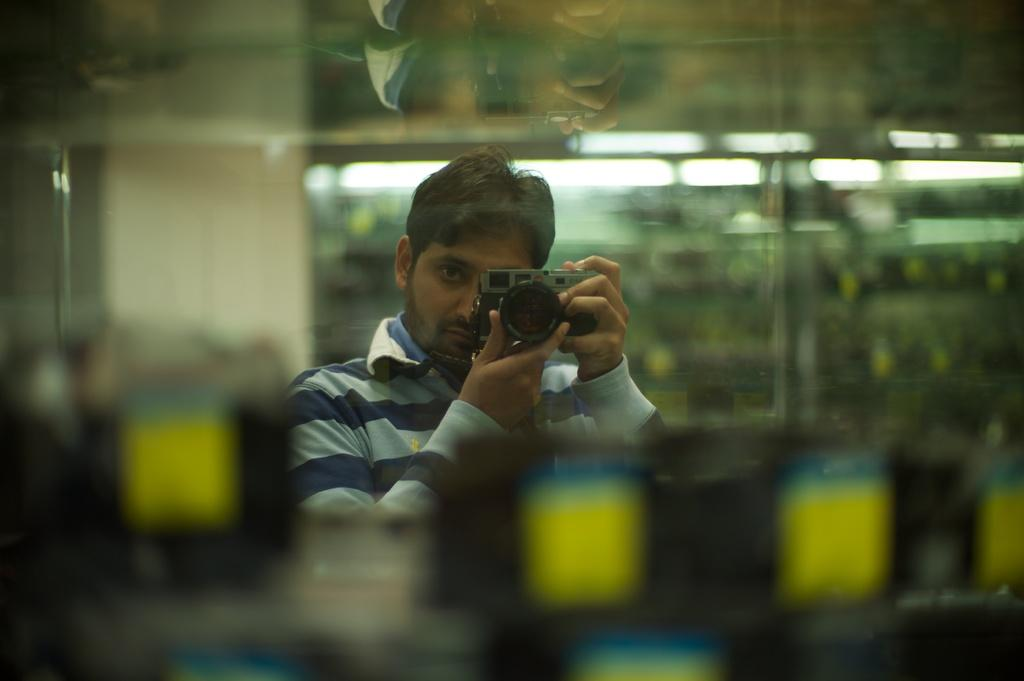Who is the main subject in the image? There is a man in the image. What is the man holding in his hands? The man is holding a camera in his hands. Can you describe the background of the image? The background of the image is blurry. What else can be seen in the background of the image? There are lights visible in the background of the image. What type of smile can be seen on the earth in the image? There is no earth present in the image, and therefore no smile can be observed. 